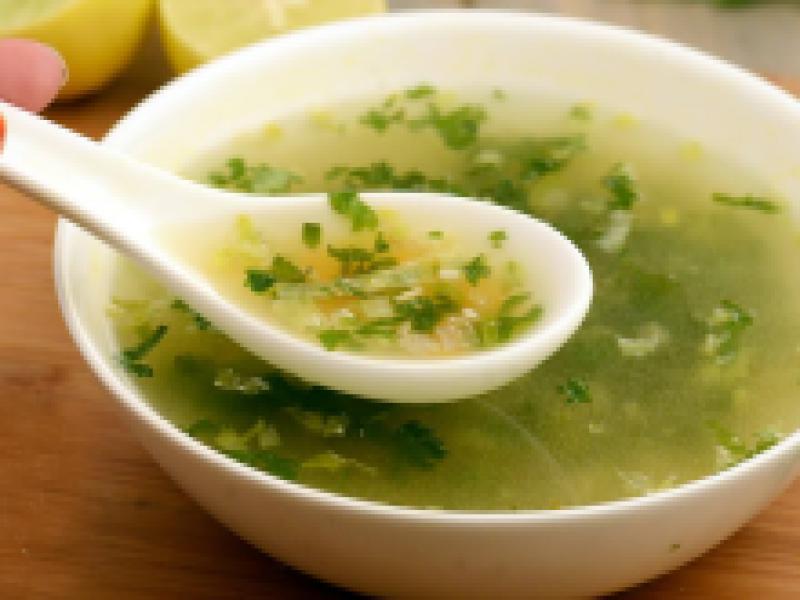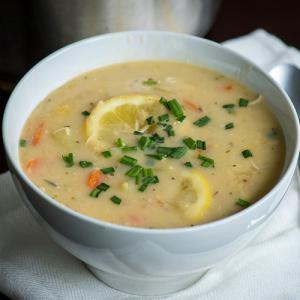The first image is the image on the left, the second image is the image on the right. Considering the images on both sides, is "A silverware spoon is lying on a flat surface nex to a white bowl containing soup." valid? Answer yes or no. No. The first image is the image on the left, the second image is the image on the right. For the images shown, is this caption "A white spoon is sitting in the bowl in one of the images." true? Answer yes or no. Yes. 